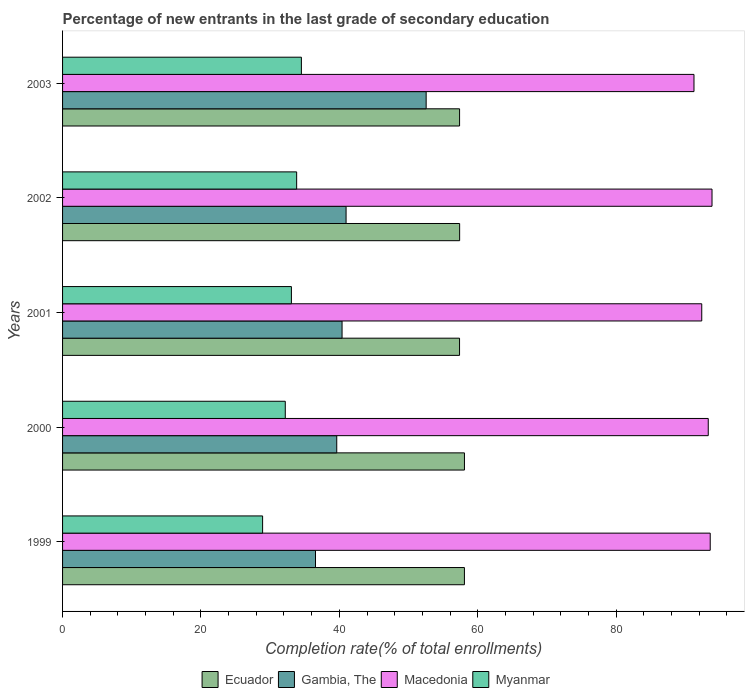How many groups of bars are there?
Your answer should be compact. 5. Are the number of bars per tick equal to the number of legend labels?
Your answer should be very brief. Yes. How many bars are there on the 3rd tick from the top?
Provide a succinct answer. 4. What is the label of the 1st group of bars from the top?
Your response must be concise. 2003. In how many cases, is the number of bars for a given year not equal to the number of legend labels?
Provide a short and direct response. 0. What is the percentage of new entrants in Gambia, The in 2001?
Give a very brief answer. 40.39. Across all years, what is the maximum percentage of new entrants in Myanmar?
Give a very brief answer. 34.51. Across all years, what is the minimum percentage of new entrants in Ecuador?
Your answer should be very brief. 57.37. In which year was the percentage of new entrants in Macedonia maximum?
Make the answer very short. 2002. What is the total percentage of new entrants in Myanmar in the graph?
Make the answer very short. 162.52. What is the difference between the percentage of new entrants in Gambia, The in 2001 and that in 2002?
Keep it short and to the point. -0.58. What is the difference between the percentage of new entrants in Myanmar in 2000 and the percentage of new entrants in Gambia, The in 2001?
Ensure brevity in your answer.  -8.21. What is the average percentage of new entrants in Myanmar per year?
Your response must be concise. 32.5. In the year 2000, what is the difference between the percentage of new entrants in Macedonia and percentage of new entrants in Ecuador?
Offer a very short reply. 35.23. What is the ratio of the percentage of new entrants in Macedonia in 2000 to that in 2001?
Provide a short and direct response. 1.01. Is the percentage of new entrants in Ecuador in 1999 less than that in 2001?
Offer a terse response. No. Is the difference between the percentage of new entrants in Macedonia in 2001 and 2002 greater than the difference between the percentage of new entrants in Ecuador in 2001 and 2002?
Give a very brief answer. No. What is the difference between the highest and the second highest percentage of new entrants in Myanmar?
Offer a terse response. 0.68. What is the difference between the highest and the lowest percentage of new entrants in Gambia, The?
Provide a short and direct response. 15.99. Is it the case that in every year, the sum of the percentage of new entrants in Ecuador and percentage of new entrants in Macedonia is greater than the sum of percentage of new entrants in Gambia, The and percentage of new entrants in Myanmar?
Your answer should be very brief. Yes. What does the 2nd bar from the top in 2001 represents?
Keep it short and to the point. Macedonia. What does the 3rd bar from the bottom in 2002 represents?
Provide a succinct answer. Macedonia. Is it the case that in every year, the sum of the percentage of new entrants in Gambia, The and percentage of new entrants in Ecuador is greater than the percentage of new entrants in Macedonia?
Your answer should be compact. Yes. How many bars are there?
Make the answer very short. 20. How many years are there in the graph?
Make the answer very short. 5. Are the values on the major ticks of X-axis written in scientific E-notation?
Make the answer very short. No. Does the graph contain grids?
Make the answer very short. No. How many legend labels are there?
Make the answer very short. 4. What is the title of the graph?
Your answer should be very brief. Percentage of new entrants in the last grade of secondary education. What is the label or title of the X-axis?
Make the answer very short. Completion rate(% of total enrollments). What is the label or title of the Y-axis?
Offer a terse response. Years. What is the Completion rate(% of total enrollments) in Ecuador in 1999?
Your answer should be compact. 58.08. What is the Completion rate(% of total enrollments) of Gambia, The in 1999?
Give a very brief answer. 36.55. What is the Completion rate(% of total enrollments) in Macedonia in 1999?
Your answer should be very brief. 93.6. What is the Completion rate(% of total enrollments) of Myanmar in 1999?
Offer a very short reply. 28.91. What is the Completion rate(% of total enrollments) of Ecuador in 2000?
Provide a short and direct response. 58.08. What is the Completion rate(% of total enrollments) of Gambia, The in 2000?
Your response must be concise. 39.63. What is the Completion rate(% of total enrollments) of Macedonia in 2000?
Provide a short and direct response. 93.31. What is the Completion rate(% of total enrollments) of Myanmar in 2000?
Ensure brevity in your answer.  32.19. What is the Completion rate(% of total enrollments) of Ecuador in 2001?
Provide a short and direct response. 57.37. What is the Completion rate(% of total enrollments) of Gambia, The in 2001?
Ensure brevity in your answer.  40.39. What is the Completion rate(% of total enrollments) of Macedonia in 2001?
Your answer should be compact. 92.37. What is the Completion rate(% of total enrollments) of Myanmar in 2001?
Ensure brevity in your answer.  33.07. What is the Completion rate(% of total enrollments) in Ecuador in 2002?
Your answer should be compact. 57.38. What is the Completion rate(% of total enrollments) in Gambia, The in 2002?
Your response must be concise. 40.97. What is the Completion rate(% of total enrollments) of Macedonia in 2002?
Keep it short and to the point. 93.86. What is the Completion rate(% of total enrollments) in Myanmar in 2002?
Keep it short and to the point. 33.83. What is the Completion rate(% of total enrollments) in Ecuador in 2003?
Make the answer very short. 57.38. What is the Completion rate(% of total enrollments) of Gambia, The in 2003?
Your answer should be very brief. 52.55. What is the Completion rate(% of total enrollments) of Macedonia in 2003?
Ensure brevity in your answer.  91.25. What is the Completion rate(% of total enrollments) in Myanmar in 2003?
Keep it short and to the point. 34.51. Across all years, what is the maximum Completion rate(% of total enrollments) of Ecuador?
Provide a succinct answer. 58.08. Across all years, what is the maximum Completion rate(% of total enrollments) of Gambia, The?
Your answer should be compact. 52.55. Across all years, what is the maximum Completion rate(% of total enrollments) in Macedonia?
Give a very brief answer. 93.86. Across all years, what is the maximum Completion rate(% of total enrollments) of Myanmar?
Offer a terse response. 34.51. Across all years, what is the minimum Completion rate(% of total enrollments) in Ecuador?
Your response must be concise. 57.37. Across all years, what is the minimum Completion rate(% of total enrollments) in Gambia, The?
Make the answer very short. 36.55. Across all years, what is the minimum Completion rate(% of total enrollments) in Macedonia?
Your response must be concise. 91.25. Across all years, what is the minimum Completion rate(% of total enrollments) in Myanmar?
Give a very brief answer. 28.91. What is the total Completion rate(% of total enrollments) of Ecuador in the graph?
Keep it short and to the point. 288.29. What is the total Completion rate(% of total enrollments) in Gambia, The in the graph?
Your answer should be compact. 210.09. What is the total Completion rate(% of total enrollments) of Macedonia in the graph?
Ensure brevity in your answer.  464.4. What is the total Completion rate(% of total enrollments) of Myanmar in the graph?
Your answer should be very brief. 162.52. What is the difference between the Completion rate(% of total enrollments) of Ecuador in 1999 and that in 2000?
Keep it short and to the point. -0.01. What is the difference between the Completion rate(% of total enrollments) in Gambia, The in 1999 and that in 2000?
Provide a succinct answer. -3.07. What is the difference between the Completion rate(% of total enrollments) of Macedonia in 1999 and that in 2000?
Your response must be concise. 0.28. What is the difference between the Completion rate(% of total enrollments) in Myanmar in 1999 and that in 2000?
Keep it short and to the point. -3.28. What is the difference between the Completion rate(% of total enrollments) of Ecuador in 1999 and that in 2001?
Provide a succinct answer. 0.71. What is the difference between the Completion rate(% of total enrollments) in Gambia, The in 1999 and that in 2001?
Give a very brief answer. -3.84. What is the difference between the Completion rate(% of total enrollments) of Macedonia in 1999 and that in 2001?
Provide a short and direct response. 1.22. What is the difference between the Completion rate(% of total enrollments) in Myanmar in 1999 and that in 2001?
Your response must be concise. -4.16. What is the difference between the Completion rate(% of total enrollments) of Ecuador in 1999 and that in 2002?
Give a very brief answer. 0.69. What is the difference between the Completion rate(% of total enrollments) of Gambia, The in 1999 and that in 2002?
Ensure brevity in your answer.  -4.42. What is the difference between the Completion rate(% of total enrollments) of Macedonia in 1999 and that in 2002?
Give a very brief answer. -0.26. What is the difference between the Completion rate(% of total enrollments) in Myanmar in 1999 and that in 2002?
Give a very brief answer. -4.92. What is the difference between the Completion rate(% of total enrollments) of Ecuador in 1999 and that in 2003?
Your response must be concise. 0.7. What is the difference between the Completion rate(% of total enrollments) of Gambia, The in 1999 and that in 2003?
Provide a short and direct response. -15.99. What is the difference between the Completion rate(% of total enrollments) in Macedonia in 1999 and that in 2003?
Provide a succinct answer. 2.35. What is the difference between the Completion rate(% of total enrollments) of Myanmar in 1999 and that in 2003?
Your answer should be very brief. -5.6. What is the difference between the Completion rate(% of total enrollments) in Ecuador in 2000 and that in 2001?
Offer a terse response. 0.71. What is the difference between the Completion rate(% of total enrollments) in Gambia, The in 2000 and that in 2001?
Keep it short and to the point. -0.77. What is the difference between the Completion rate(% of total enrollments) in Macedonia in 2000 and that in 2001?
Make the answer very short. 0.94. What is the difference between the Completion rate(% of total enrollments) of Myanmar in 2000 and that in 2001?
Offer a very short reply. -0.88. What is the difference between the Completion rate(% of total enrollments) of Ecuador in 2000 and that in 2002?
Provide a short and direct response. 0.7. What is the difference between the Completion rate(% of total enrollments) of Gambia, The in 2000 and that in 2002?
Provide a short and direct response. -1.35. What is the difference between the Completion rate(% of total enrollments) in Macedonia in 2000 and that in 2002?
Ensure brevity in your answer.  -0.54. What is the difference between the Completion rate(% of total enrollments) of Myanmar in 2000 and that in 2002?
Your answer should be compact. -1.64. What is the difference between the Completion rate(% of total enrollments) of Ecuador in 2000 and that in 2003?
Your answer should be compact. 0.7. What is the difference between the Completion rate(% of total enrollments) in Gambia, The in 2000 and that in 2003?
Your response must be concise. -12.92. What is the difference between the Completion rate(% of total enrollments) of Macedonia in 2000 and that in 2003?
Your answer should be compact. 2.06. What is the difference between the Completion rate(% of total enrollments) in Myanmar in 2000 and that in 2003?
Keep it short and to the point. -2.33. What is the difference between the Completion rate(% of total enrollments) of Ecuador in 2001 and that in 2002?
Give a very brief answer. -0.01. What is the difference between the Completion rate(% of total enrollments) in Gambia, The in 2001 and that in 2002?
Offer a terse response. -0.58. What is the difference between the Completion rate(% of total enrollments) in Macedonia in 2001 and that in 2002?
Your response must be concise. -1.49. What is the difference between the Completion rate(% of total enrollments) of Myanmar in 2001 and that in 2002?
Give a very brief answer. -0.76. What is the difference between the Completion rate(% of total enrollments) of Ecuador in 2001 and that in 2003?
Offer a very short reply. -0.01. What is the difference between the Completion rate(% of total enrollments) in Gambia, The in 2001 and that in 2003?
Offer a very short reply. -12.15. What is the difference between the Completion rate(% of total enrollments) of Macedonia in 2001 and that in 2003?
Offer a terse response. 1.12. What is the difference between the Completion rate(% of total enrollments) in Myanmar in 2001 and that in 2003?
Your answer should be compact. -1.44. What is the difference between the Completion rate(% of total enrollments) in Ecuador in 2002 and that in 2003?
Your answer should be compact. 0.01. What is the difference between the Completion rate(% of total enrollments) of Gambia, The in 2002 and that in 2003?
Offer a terse response. -11.57. What is the difference between the Completion rate(% of total enrollments) in Macedonia in 2002 and that in 2003?
Offer a very short reply. 2.61. What is the difference between the Completion rate(% of total enrollments) of Myanmar in 2002 and that in 2003?
Keep it short and to the point. -0.68. What is the difference between the Completion rate(% of total enrollments) in Ecuador in 1999 and the Completion rate(% of total enrollments) in Gambia, The in 2000?
Your response must be concise. 18.45. What is the difference between the Completion rate(% of total enrollments) of Ecuador in 1999 and the Completion rate(% of total enrollments) of Macedonia in 2000?
Keep it short and to the point. -35.24. What is the difference between the Completion rate(% of total enrollments) of Ecuador in 1999 and the Completion rate(% of total enrollments) of Myanmar in 2000?
Provide a succinct answer. 25.89. What is the difference between the Completion rate(% of total enrollments) of Gambia, The in 1999 and the Completion rate(% of total enrollments) of Macedonia in 2000?
Offer a terse response. -56.76. What is the difference between the Completion rate(% of total enrollments) in Gambia, The in 1999 and the Completion rate(% of total enrollments) in Myanmar in 2000?
Provide a succinct answer. 4.37. What is the difference between the Completion rate(% of total enrollments) in Macedonia in 1999 and the Completion rate(% of total enrollments) in Myanmar in 2000?
Keep it short and to the point. 61.41. What is the difference between the Completion rate(% of total enrollments) of Ecuador in 1999 and the Completion rate(% of total enrollments) of Gambia, The in 2001?
Give a very brief answer. 17.68. What is the difference between the Completion rate(% of total enrollments) of Ecuador in 1999 and the Completion rate(% of total enrollments) of Macedonia in 2001?
Your answer should be very brief. -34.3. What is the difference between the Completion rate(% of total enrollments) in Ecuador in 1999 and the Completion rate(% of total enrollments) in Myanmar in 2001?
Provide a short and direct response. 25. What is the difference between the Completion rate(% of total enrollments) of Gambia, The in 1999 and the Completion rate(% of total enrollments) of Macedonia in 2001?
Ensure brevity in your answer.  -55.82. What is the difference between the Completion rate(% of total enrollments) in Gambia, The in 1999 and the Completion rate(% of total enrollments) in Myanmar in 2001?
Offer a terse response. 3.48. What is the difference between the Completion rate(% of total enrollments) in Macedonia in 1999 and the Completion rate(% of total enrollments) in Myanmar in 2001?
Your answer should be compact. 60.53. What is the difference between the Completion rate(% of total enrollments) of Ecuador in 1999 and the Completion rate(% of total enrollments) of Gambia, The in 2002?
Give a very brief answer. 17.1. What is the difference between the Completion rate(% of total enrollments) in Ecuador in 1999 and the Completion rate(% of total enrollments) in Macedonia in 2002?
Provide a succinct answer. -35.78. What is the difference between the Completion rate(% of total enrollments) in Ecuador in 1999 and the Completion rate(% of total enrollments) in Myanmar in 2002?
Offer a terse response. 24.24. What is the difference between the Completion rate(% of total enrollments) of Gambia, The in 1999 and the Completion rate(% of total enrollments) of Macedonia in 2002?
Provide a short and direct response. -57.31. What is the difference between the Completion rate(% of total enrollments) in Gambia, The in 1999 and the Completion rate(% of total enrollments) in Myanmar in 2002?
Make the answer very short. 2.72. What is the difference between the Completion rate(% of total enrollments) of Macedonia in 1999 and the Completion rate(% of total enrollments) of Myanmar in 2002?
Make the answer very short. 59.77. What is the difference between the Completion rate(% of total enrollments) in Ecuador in 1999 and the Completion rate(% of total enrollments) in Gambia, The in 2003?
Give a very brief answer. 5.53. What is the difference between the Completion rate(% of total enrollments) of Ecuador in 1999 and the Completion rate(% of total enrollments) of Macedonia in 2003?
Make the answer very short. -33.18. What is the difference between the Completion rate(% of total enrollments) in Ecuador in 1999 and the Completion rate(% of total enrollments) in Myanmar in 2003?
Offer a very short reply. 23.56. What is the difference between the Completion rate(% of total enrollments) in Gambia, The in 1999 and the Completion rate(% of total enrollments) in Macedonia in 2003?
Provide a succinct answer. -54.7. What is the difference between the Completion rate(% of total enrollments) in Gambia, The in 1999 and the Completion rate(% of total enrollments) in Myanmar in 2003?
Your answer should be compact. 2.04. What is the difference between the Completion rate(% of total enrollments) in Macedonia in 1999 and the Completion rate(% of total enrollments) in Myanmar in 2003?
Your answer should be very brief. 59.08. What is the difference between the Completion rate(% of total enrollments) in Ecuador in 2000 and the Completion rate(% of total enrollments) in Gambia, The in 2001?
Give a very brief answer. 17.69. What is the difference between the Completion rate(% of total enrollments) in Ecuador in 2000 and the Completion rate(% of total enrollments) in Macedonia in 2001?
Offer a very short reply. -34.29. What is the difference between the Completion rate(% of total enrollments) in Ecuador in 2000 and the Completion rate(% of total enrollments) in Myanmar in 2001?
Give a very brief answer. 25.01. What is the difference between the Completion rate(% of total enrollments) in Gambia, The in 2000 and the Completion rate(% of total enrollments) in Macedonia in 2001?
Your answer should be compact. -52.75. What is the difference between the Completion rate(% of total enrollments) in Gambia, The in 2000 and the Completion rate(% of total enrollments) in Myanmar in 2001?
Your answer should be compact. 6.55. What is the difference between the Completion rate(% of total enrollments) in Macedonia in 2000 and the Completion rate(% of total enrollments) in Myanmar in 2001?
Offer a terse response. 60.24. What is the difference between the Completion rate(% of total enrollments) of Ecuador in 2000 and the Completion rate(% of total enrollments) of Gambia, The in 2002?
Keep it short and to the point. 17.11. What is the difference between the Completion rate(% of total enrollments) in Ecuador in 2000 and the Completion rate(% of total enrollments) in Macedonia in 2002?
Your response must be concise. -35.78. What is the difference between the Completion rate(% of total enrollments) in Ecuador in 2000 and the Completion rate(% of total enrollments) in Myanmar in 2002?
Your answer should be compact. 24.25. What is the difference between the Completion rate(% of total enrollments) of Gambia, The in 2000 and the Completion rate(% of total enrollments) of Macedonia in 2002?
Provide a succinct answer. -54.23. What is the difference between the Completion rate(% of total enrollments) in Gambia, The in 2000 and the Completion rate(% of total enrollments) in Myanmar in 2002?
Offer a very short reply. 5.79. What is the difference between the Completion rate(% of total enrollments) of Macedonia in 2000 and the Completion rate(% of total enrollments) of Myanmar in 2002?
Provide a succinct answer. 59.48. What is the difference between the Completion rate(% of total enrollments) of Ecuador in 2000 and the Completion rate(% of total enrollments) of Gambia, The in 2003?
Your answer should be very brief. 5.54. What is the difference between the Completion rate(% of total enrollments) of Ecuador in 2000 and the Completion rate(% of total enrollments) of Macedonia in 2003?
Give a very brief answer. -33.17. What is the difference between the Completion rate(% of total enrollments) in Ecuador in 2000 and the Completion rate(% of total enrollments) in Myanmar in 2003?
Offer a very short reply. 23.57. What is the difference between the Completion rate(% of total enrollments) of Gambia, The in 2000 and the Completion rate(% of total enrollments) of Macedonia in 2003?
Give a very brief answer. -51.63. What is the difference between the Completion rate(% of total enrollments) in Gambia, The in 2000 and the Completion rate(% of total enrollments) in Myanmar in 2003?
Provide a succinct answer. 5.11. What is the difference between the Completion rate(% of total enrollments) of Macedonia in 2000 and the Completion rate(% of total enrollments) of Myanmar in 2003?
Your answer should be compact. 58.8. What is the difference between the Completion rate(% of total enrollments) in Ecuador in 2001 and the Completion rate(% of total enrollments) in Gambia, The in 2002?
Keep it short and to the point. 16.4. What is the difference between the Completion rate(% of total enrollments) in Ecuador in 2001 and the Completion rate(% of total enrollments) in Macedonia in 2002?
Provide a succinct answer. -36.49. What is the difference between the Completion rate(% of total enrollments) in Ecuador in 2001 and the Completion rate(% of total enrollments) in Myanmar in 2002?
Offer a terse response. 23.54. What is the difference between the Completion rate(% of total enrollments) of Gambia, The in 2001 and the Completion rate(% of total enrollments) of Macedonia in 2002?
Give a very brief answer. -53.47. What is the difference between the Completion rate(% of total enrollments) of Gambia, The in 2001 and the Completion rate(% of total enrollments) of Myanmar in 2002?
Keep it short and to the point. 6.56. What is the difference between the Completion rate(% of total enrollments) of Macedonia in 2001 and the Completion rate(% of total enrollments) of Myanmar in 2002?
Provide a short and direct response. 58.54. What is the difference between the Completion rate(% of total enrollments) of Ecuador in 2001 and the Completion rate(% of total enrollments) of Gambia, The in 2003?
Ensure brevity in your answer.  4.83. What is the difference between the Completion rate(% of total enrollments) in Ecuador in 2001 and the Completion rate(% of total enrollments) in Macedonia in 2003?
Your answer should be compact. -33.88. What is the difference between the Completion rate(% of total enrollments) of Ecuador in 2001 and the Completion rate(% of total enrollments) of Myanmar in 2003?
Offer a terse response. 22.86. What is the difference between the Completion rate(% of total enrollments) in Gambia, The in 2001 and the Completion rate(% of total enrollments) in Macedonia in 2003?
Your response must be concise. -50.86. What is the difference between the Completion rate(% of total enrollments) of Gambia, The in 2001 and the Completion rate(% of total enrollments) of Myanmar in 2003?
Your answer should be compact. 5.88. What is the difference between the Completion rate(% of total enrollments) of Macedonia in 2001 and the Completion rate(% of total enrollments) of Myanmar in 2003?
Make the answer very short. 57.86. What is the difference between the Completion rate(% of total enrollments) in Ecuador in 2002 and the Completion rate(% of total enrollments) in Gambia, The in 2003?
Offer a terse response. 4.84. What is the difference between the Completion rate(% of total enrollments) in Ecuador in 2002 and the Completion rate(% of total enrollments) in Macedonia in 2003?
Your answer should be very brief. -33.87. What is the difference between the Completion rate(% of total enrollments) of Ecuador in 2002 and the Completion rate(% of total enrollments) of Myanmar in 2003?
Your answer should be very brief. 22.87. What is the difference between the Completion rate(% of total enrollments) in Gambia, The in 2002 and the Completion rate(% of total enrollments) in Macedonia in 2003?
Provide a succinct answer. -50.28. What is the difference between the Completion rate(% of total enrollments) of Gambia, The in 2002 and the Completion rate(% of total enrollments) of Myanmar in 2003?
Your response must be concise. 6.46. What is the difference between the Completion rate(% of total enrollments) of Macedonia in 2002 and the Completion rate(% of total enrollments) of Myanmar in 2003?
Your answer should be compact. 59.34. What is the average Completion rate(% of total enrollments) in Ecuador per year?
Make the answer very short. 57.66. What is the average Completion rate(% of total enrollments) of Gambia, The per year?
Your answer should be very brief. 42.02. What is the average Completion rate(% of total enrollments) of Macedonia per year?
Offer a very short reply. 92.88. What is the average Completion rate(% of total enrollments) in Myanmar per year?
Offer a very short reply. 32.5. In the year 1999, what is the difference between the Completion rate(% of total enrollments) of Ecuador and Completion rate(% of total enrollments) of Gambia, The?
Offer a terse response. 21.52. In the year 1999, what is the difference between the Completion rate(% of total enrollments) of Ecuador and Completion rate(% of total enrollments) of Macedonia?
Keep it short and to the point. -35.52. In the year 1999, what is the difference between the Completion rate(% of total enrollments) of Ecuador and Completion rate(% of total enrollments) of Myanmar?
Ensure brevity in your answer.  29.17. In the year 1999, what is the difference between the Completion rate(% of total enrollments) of Gambia, The and Completion rate(% of total enrollments) of Macedonia?
Offer a very short reply. -57.05. In the year 1999, what is the difference between the Completion rate(% of total enrollments) of Gambia, The and Completion rate(% of total enrollments) of Myanmar?
Provide a short and direct response. 7.64. In the year 1999, what is the difference between the Completion rate(% of total enrollments) of Macedonia and Completion rate(% of total enrollments) of Myanmar?
Keep it short and to the point. 64.69. In the year 2000, what is the difference between the Completion rate(% of total enrollments) of Ecuador and Completion rate(% of total enrollments) of Gambia, The?
Your response must be concise. 18.46. In the year 2000, what is the difference between the Completion rate(% of total enrollments) in Ecuador and Completion rate(% of total enrollments) in Macedonia?
Your response must be concise. -35.23. In the year 2000, what is the difference between the Completion rate(% of total enrollments) of Ecuador and Completion rate(% of total enrollments) of Myanmar?
Provide a succinct answer. 25.89. In the year 2000, what is the difference between the Completion rate(% of total enrollments) of Gambia, The and Completion rate(% of total enrollments) of Macedonia?
Offer a very short reply. -53.69. In the year 2000, what is the difference between the Completion rate(% of total enrollments) in Gambia, The and Completion rate(% of total enrollments) in Myanmar?
Ensure brevity in your answer.  7.44. In the year 2000, what is the difference between the Completion rate(% of total enrollments) of Macedonia and Completion rate(% of total enrollments) of Myanmar?
Provide a short and direct response. 61.13. In the year 2001, what is the difference between the Completion rate(% of total enrollments) of Ecuador and Completion rate(% of total enrollments) of Gambia, The?
Offer a very short reply. 16.98. In the year 2001, what is the difference between the Completion rate(% of total enrollments) of Ecuador and Completion rate(% of total enrollments) of Macedonia?
Ensure brevity in your answer.  -35. In the year 2001, what is the difference between the Completion rate(% of total enrollments) in Ecuador and Completion rate(% of total enrollments) in Myanmar?
Ensure brevity in your answer.  24.3. In the year 2001, what is the difference between the Completion rate(% of total enrollments) in Gambia, The and Completion rate(% of total enrollments) in Macedonia?
Offer a very short reply. -51.98. In the year 2001, what is the difference between the Completion rate(% of total enrollments) in Gambia, The and Completion rate(% of total enrollments) in Myanmar?
Offer a terse response. 7.32. In the year 2001, what is the difference between the Completion rate(% of total enrollments) of Macedonia and Completion rate(% of total enrollments) of Myanmar?
Your response must be concise. 59.3. In the year 2002, what is the difference between the Completion rate(% of total enrollments) in Ecuador and Completion rate(% of total enrollments) in Gambia, The?
Offer a terse response. 16.41. In the year 2002, what is the difference between the Completion rate(% of total enrollments) in Ecuador and Completion rate(% of total enrollments) in Macedonia?
Keep it short and to the point. -36.47. In the year 2002, what is the difference between the Completion rate(% of total enrollments) of Ecuador and Completion rate(% of total enrollments) of Myanmar?
Keep it short and to the point. 23.55. In the year 2002, what is the difference between the Completion rate(% of total enrollments) in Gambia, The and Completion rate(% of total enrollments) in Macedonia?
Offer a very short reply. -52.89. In the year 2002, what is the difference between the Completion rate(% of total enrollments) in Gambia, The and Completion rate(% of total enrollments) in Myanmar?
Ensure brevity in your answer.  7.14. In the year 2002, what is the difference between the Completion rate(% of total enrollments) in Macedonia and Completion rate(% of total enrollments) in Myanmar?
Make the answer very short. 60.03. In the year 2003, what is the difference between the Completion rate(% of total enrollments) in Ecuador and Completion rate(% of total enrollments) in Gambia, The?
Your response must be concise. 4.83. In the year 2003, what is the difference between the Completion rate(% of total enrollments) of Ecuador and Completion rate(% of total enrollments) of Macedonia?
Keep it short and to the point. -33.88. In the year 2003, what is the difference between the Completion rate(% of total enrollments) of Ecuador and Completion rate(% of total enrollments) of Myanmar?
Provide a succinct answer. 22.86. In the year 2003, what is the difference between the Completion rate(% of total enrollments) in Gambia, The and Completion rate(% of total enrollments) in Macedonia?
Provide a succinct answer. -38.71. In the year 2003, what is the difference between the Completion rate(% of total enrollments) of Gambia, The and Completion rate(% of total enrollments) of Myanmar?
Keep it short and to the point. 18.03. In the year 2003, what is the difference between the Completion rate(% of total enrollments) in Macedonia and Completion rate(% of total enrollments) in Myanmar?
Give a very brief answer. 56.74. What is the ratio of the Completion rate(% of total enrollments) of Ecuador in 1999 to that in 2000?
Provide a succinct answer. 1. What is the ratio of the Completion rate(% of total enrollments) of Gambia, The in 1999 to that in 2000?
Give a very brief answer. 0.92. What is the ratio of the Completion rate(% of total enrollments) of Macedonia in 1999 to that in 2000?
Keep it short and to the point. 1. What is the ratio of the Completion rate(% of total enrollments) of Myanmar in 1999 to that in 2000?
Provide a succinct answer. 0.9. What is the ratio of the Completion rate(% of total enrollments) of Ecuador in 1999 to that in 2001?
Your answer should be compact. 1.01. What is the ratio of the Completion rate(% of total enrollments) of Gambia, The in 1999 to that in 2001?
Give a very brief answer. 0.9. What is the ratio of the Completion rate(% of total enrollments) in Macedonia in 1999 to that in 2001?
Offer a very short reply. 1.01. What is the ratio of the Completion rate(% of total enrollments) of Myanmar in 1999 to that in 2001?
Give a very brief answer. 0.87. What is the ratio of the Completion rate(% of total enrollments) in Ecuador in 1999 to that in 2002?
Keep it short and to the point. 1.01. What is the ratio of the Completion rate(% of total enrollments) of Gambia, The in 1999 to that in 2002?
Give a very brief answer. 0.89. What is the ratio of the Completion rate(% of total enrollments) of Macedonia in 1999 to that in 2002?
Give a very brief answer. 1. What is the ratio of the Completion rate(% of total enrollments) of Myanmar in 1999 to that in 2002?
Give a very brief answer. 0.85. What is the ratio of the Completion rate(% of total enrollments) of Ecuador in 1999 to that in 2003?
Provide a short and direct response. 1.01. What is the ratio of the Completion rate(% of total enrollments) of Gambia, The in 1999 to that in 2003?
Your response must be concise. 0.7. What is the ratio of the Completion rate(% of total enrollments) of Macedonia in 1999 to that in 2003?
Keep it short and to the point. 1.03. What is the ratio of the Completion rate(% of total enrollments) in Myanmar in 1999 to that in 2003?
Give a very brief answer. 0.84. What is the ratio of the Completion rate(% of total enrollments) in Ecuador in 2000 to that in 2001?
Provide a short and direct response. 1.01. What is the ratio of the Completion rate(% of total enrollments) in Macedonia in 2000 to that in 2001?
Offer a very short reply. 1.01. What is the ratio of the Completion rate(% of total enrollments) of Myanmar in 2000 to that in 2001?
Make the answer very short. 0.97. What is the ratio of the Completion rate(% of total enrollments) of Ecuador in 2000 to that in 2002?
Ensure brevity in your answer.  1.01. What is the ratio of the Completion rate(% of total enrollments) in Gambia, The in 2000 to that in 2002?
Your answer should be very brief. 0.97. What is the ratio of the Completion rate(% of total enrollments) in Myanmar in 2000 to that in 2002?
Ensure brevity in your answer.  0.95. What is the ratio of the Completion rate(% of total enrollments) of Ecuador in 2000 to that in 2003?
Make the answer very short. 1.01. What is the ratio of the Completion rate(% of total enrollments) in Gambia, The in 2000 to that in 2003?
Ensure brevity in your answer.  0.75. What is the ratio of the Completion rate(% of total enrollments) of Macedonia in 2000 to that in 2003?
Your answer should be compact. 1.02. What is the ratio of the Completion rate(% of total enrollments) in Myanmar in 2000 to that in 2003?
Your response must be concise. 0.93. What is the ratio of the Completion rate(% of total enrollments) of Ecuador in 2001 to that in 2002?
Your answer should be compact. 1. What is the ratio of the Completion rate(% of total enrollments) in Gambia, The in 2001 to that in 2002?
Ensure brevity in your answer.  0.99. What is the ratio of the Completion rate(% of total enrollments) of Macedonia in 2001 to that in 2002?
Make the answer very short. 0.98. What is the ratio of the Completion rate(% of total enrollments) in Myanmar in 2001 to that in 2002?
Your answer should be very brief. 0.98. What is the ratio of the Completion rate(% of total enrollments) of Gambia, The in 2001 to that in 2003?
Give a very brief answer. 0.77. What is the ratio of the Completion rate(% of total enrollments) in Macedonia in 2001 to that in 2003?
Ensure brevity in your answer.  1.01. What is the ratio of the Completion rate(% of total enrollments) in Myanmar in 2001 to that in 2003?
Offer a terse response. 0.96. What is the ratio of the Completion rate(% of total enrollments) of Ecuador in 2002 to that in 2003?
Provide a short and direct response. 1. What is the ratio of the Completion rate(% of total enrollments) of Gambia, The in 2002 to that in 2003?
Your response must be concise. 0.78. What is the ratio of the Completion rate(% of total enrollments) of Macedonia in 2002 to that in 2003?
Keep it short and to the point. 1.03. What is the ratio of the Completion rate(% of total enrollments) in Myanmar in 2002 to that in 2003?
Give a very brief answer. 0.98. What is the difference between the highest and the second highest Completion rate(% of total enrollments) of Ecuador?
Your answer should be compact. 0.01. What is the difference between the highest and the second highest Completion rate(% of total enrollments) in Gambia, The?
Offer a terse response. 11.57. What is the difference between the highest and the second highest Completion rate(% of total enrollments) of Macedonia?
Ensure brevity in your answer.  0.26. What is the difference between the highest and the second highest Completion rate(% of total enrollments) in Myanmar?
Ensure brevity in your answer.  0.68. What is the difference between the highest and the lowest Completion rate(% of total enrollments) in Ecuador?
Provide a succinct answer. 0.71. What is the difference between the highest and the lowest Completion rate(% of total enrollments) in Gambia, The?
Give a very brief answer. 15.99. What is the difference between the highest and the lowest Completion rate(% of total enrollments) in Macedonia?
Make the answer very short. 2.61. What is the difference between the highest and the lowest Completion rate(% of total enrollments) in Myanmar?
Your response must be concise. 5.6. 